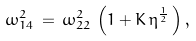<formula> <loc_0><loc_0><loc_500><loc_500>\omega _ { 1 4 } ^ { 2 } \, = \, \omega _ { 2 2 } ^ { 2 } \, \left ( 1 + K \, \eta ^ { \frac { 1 } { 2 } } \, \right ) ,</formula> 